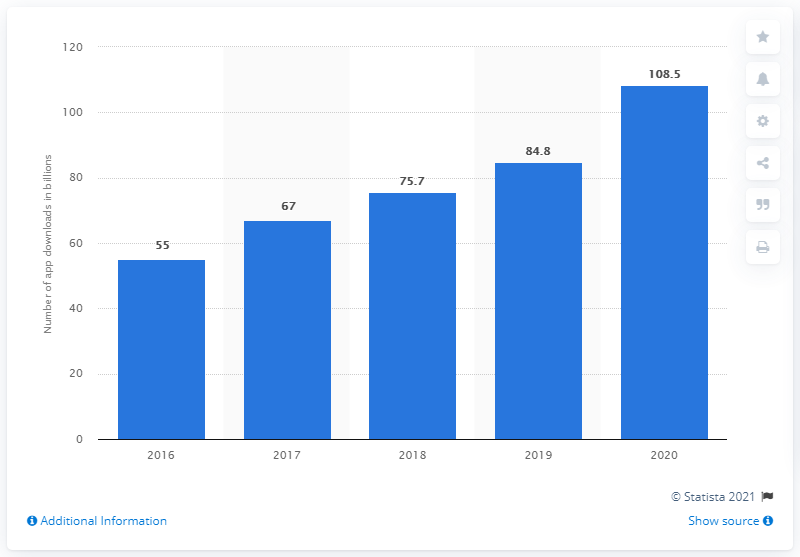Specify some key components in this picture. In 2018, users downloaded 75.7% of the apps. In 2020, Google Play users downloaded a total of 108.5 apps on average per user. 